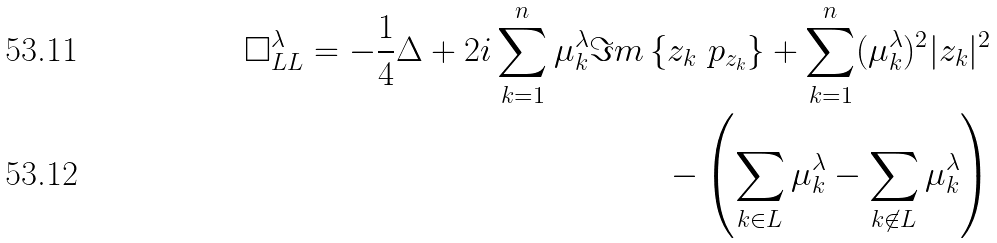Convert formula to latex. <formula><loc_0><loc_0><loc_500><loc_500>\Box _ { L L } ^ { \lambda } = - \frac { 1 } { 4 } \Delta + 2 i \sum _ { k = 1 } ^ { n } \mu ^ { \lambda } _ { k } \Im m \left \{ z _ { k } \ p _ { z _ { k } } \right \} + \sum _ { k = 1 } ^ { n } ( \mu ^ { \lambda } _ { k } ) ^ { 2 } | z _ { k } | ^ { 2 } \\ - \left ( \sum _ { k \in L } \mu ^ { \lambda } _ { k } - \sum _ { k \not \in L } \mu ^ { \lambda } _ { k } \right )</formula> 